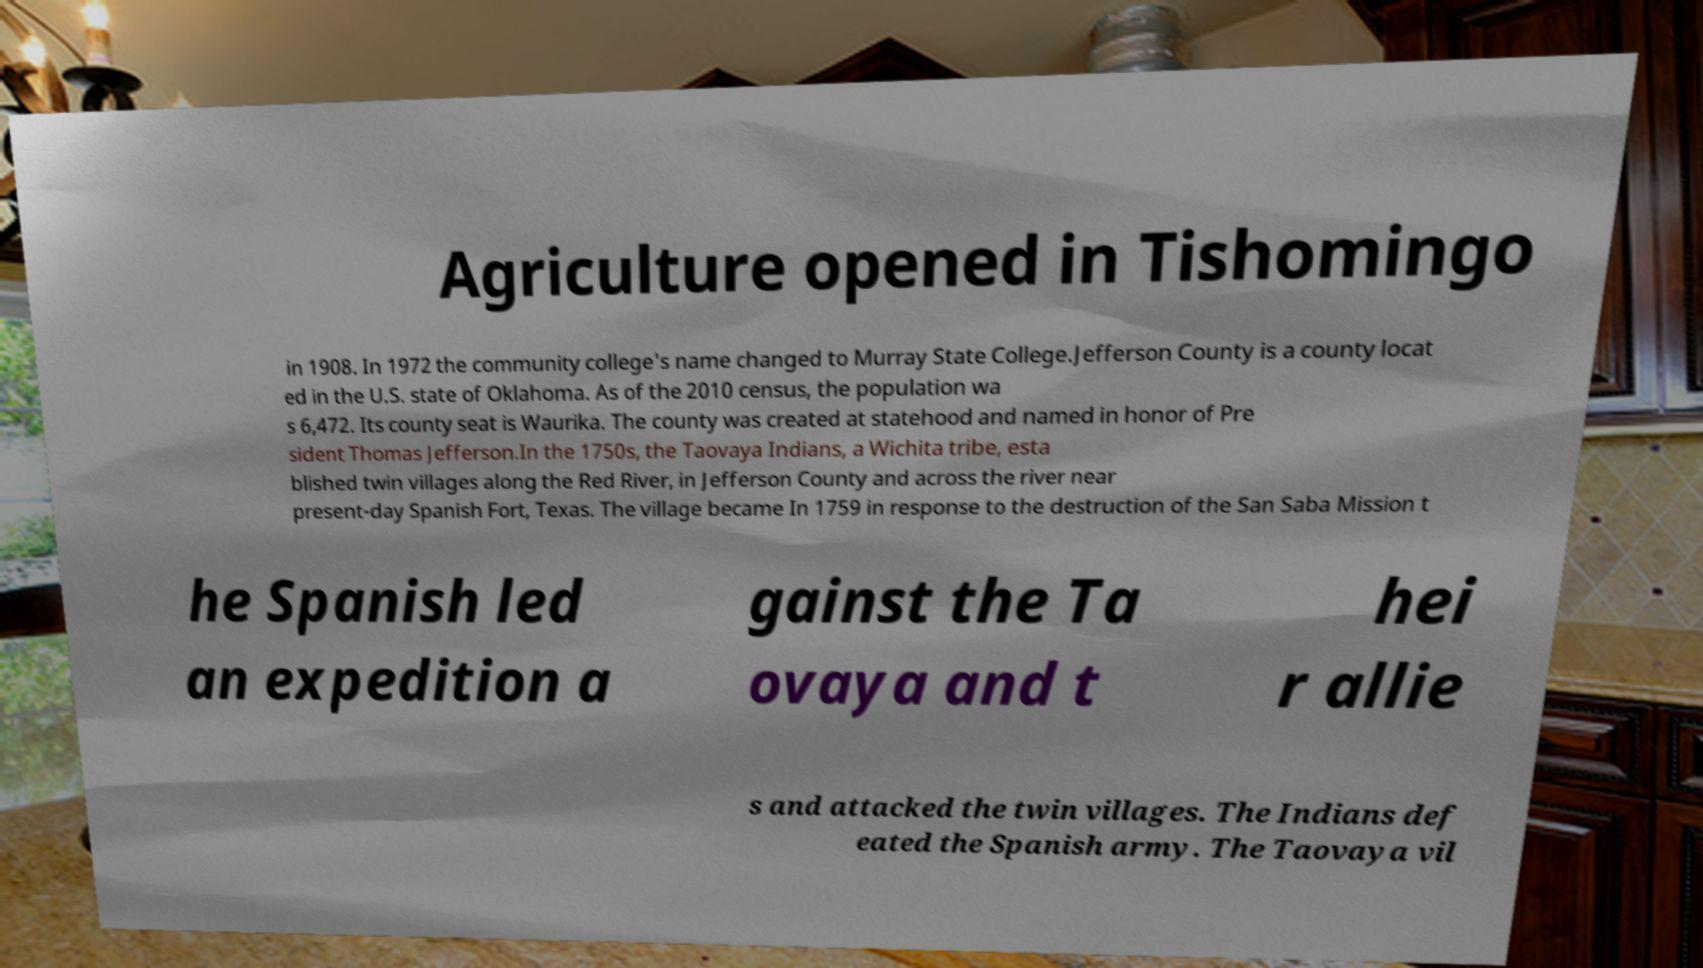Could you assist in decoding the text presented in this image and type it out clearly? Agriculture opened in Tishomingo in 1908. In 1972 the community college's name changed to Murray State College.Jefferson County is a county locat ed in the U.S. state of Oklahoma. As of the 2010 census, the population wa s 6,472. Its county seat is Waurika. The county was created at statehood and named in honor of Pre sident Thomas Jefferson.In the 1750s, the Taovaya Indians, a Wichita tribe, esta blished twin villages along the Red River, in Jefferson County and across the river near present-day Spanish Fort, Texas. The village became In 1759 in response to the destruction of the San Saba Mission t he Spanish led an expedition a gainst the Ta ovaya and t hei r allie s and attacked the twin villages. The Indians def eated the Spanish army. The Taovaya vil 